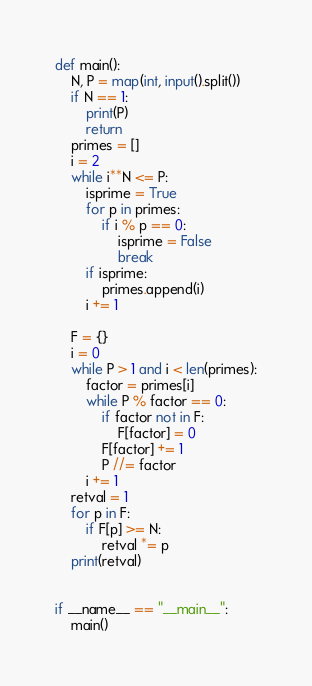<code> <loc_0><loc_0><loc_500><loc_500><_Python_>def main():
    N, P = map(int, input().split())
    if N == 1:
        print(P)
        return
    primes = []
    i = 2
    while i**N <= P:
        isprime = True
        for p in primes:
            if i % p == 0:
                isprime = False
                break
        if isprime:
            primes.append(i)
        i += 1

    F = {}
    i = 0
    while P > 1 and i < len(primes):
        factor = primes[i]
        while P % factor == 0:
            if factor not in F:
                F[factor] = 0
            F[factor] += 1
            P //= factor
        i += 1
    retval = 1
    for p in F:
        if F[p] >= N:
            retval *= p
    print(retval)


if __name__ == "__main__":
    main()
</code> 